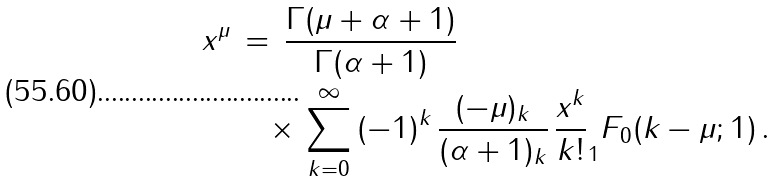Convert formula to latex. <formula><loc_0><loc_0><loc_500><loc_500>x ^ { \mu } & \, = \, \frac { \Gamma ( \mu + \alpha + 1 ) } { \Gamma ( \alpha + 1 ) } \\ & \quad \times \, \sum _ { k = 0 } ^ { \infty } \, ( - 1 ) ^ { k } \, \frac { ( - \mu ) _ { k } } { ( \alpha + 1 ) _ { k } } \, \frac { x ^ { k } } { k ! } _ { 1 } F _ { 0 } ( k - \mu ; 1 ) \, .</formula> 